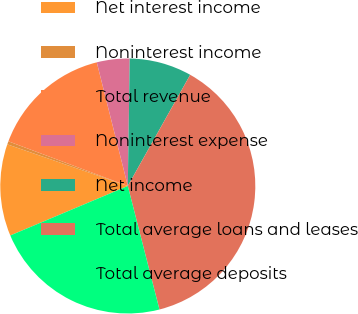Convert chart. <chart><loc_0><loc_0><loc_500><loc_500><pie_chart><fcel>Net interest income<fcel>Noninterest income<fcel>Total revenue<fcel>Noninterest expense<fcel>Net income<fcel>Total average loans and leases<fcel>Total average deposits<nl><fcel>11.64%<fcel>0.4%<fcel>15.39%<fcel>4.15%<fcel>7.9%<fcel>37.87%<fcel>22.65%<nl></chart> 